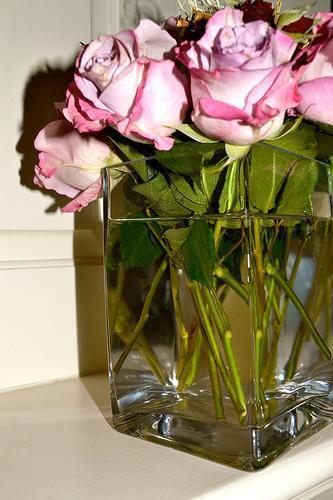How many people are in the picture?
Give a very brief answer. 0. 